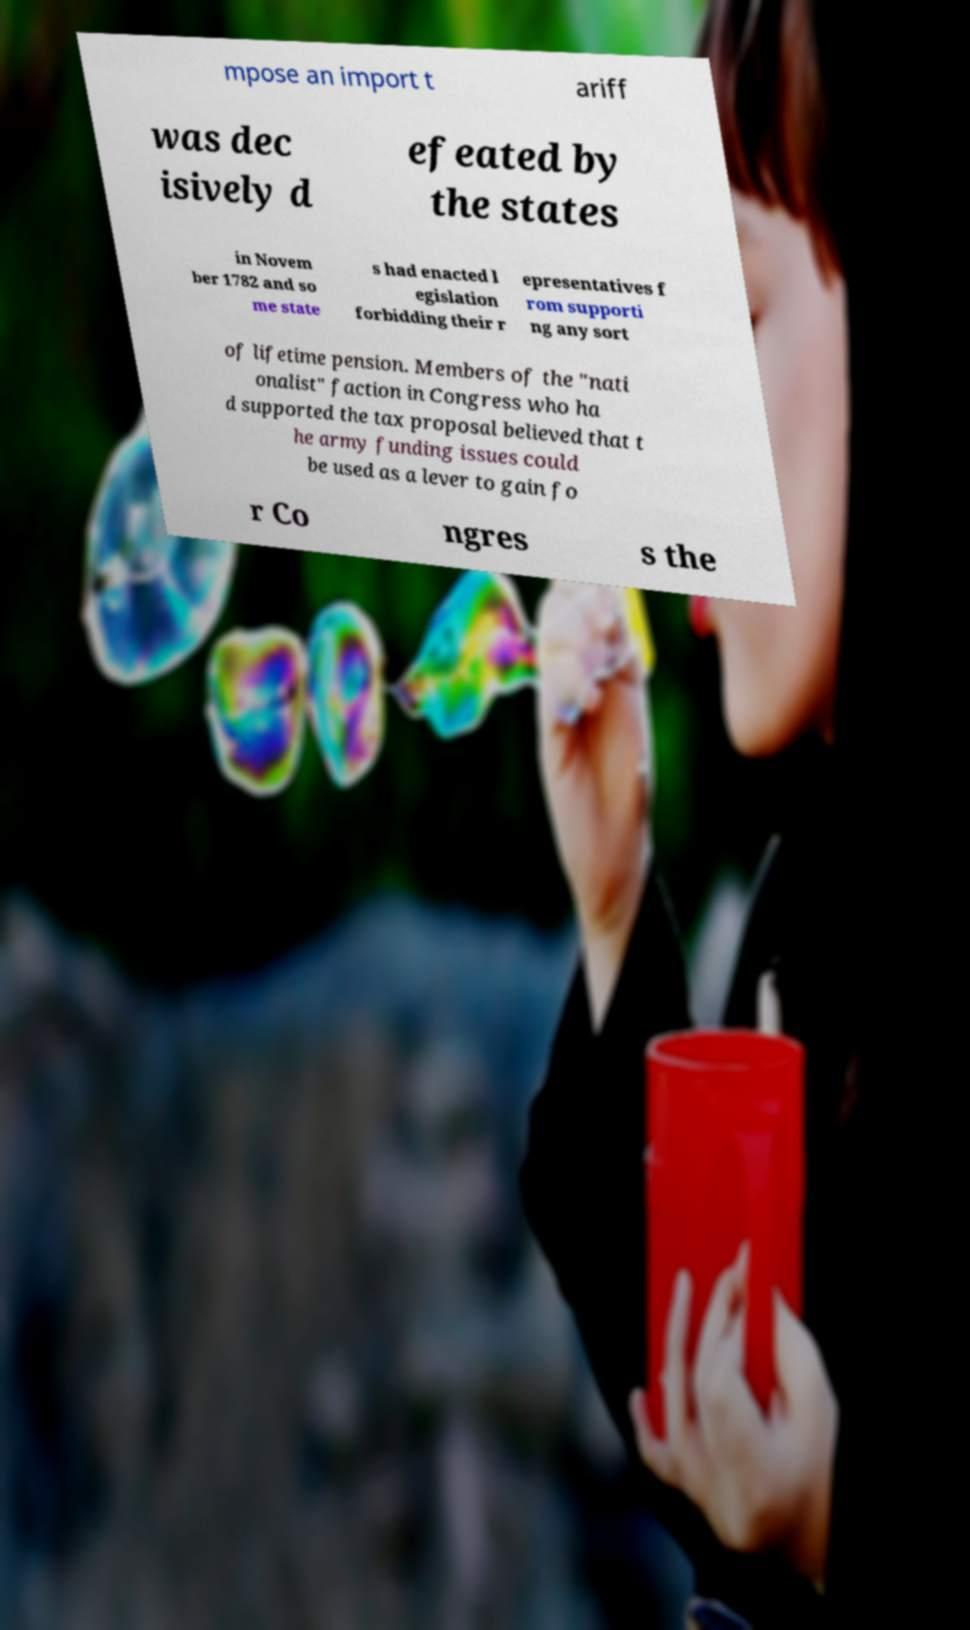I need the written content from this picture converted into text. Can you do that? mpose an import t ariff was dec isively d efeated by the states in Novem ber 1782 and so me state s had enacted l egislation forbidding their r epresentatives f rom supporti ng any sort of lifetime pension. Members of the "nati onalist" faction in Congress who ha d supported the tax proposal believed that t he army funding issues could be used as a lever to gain fo r Co ngres s the 